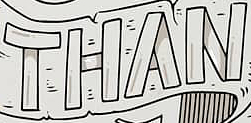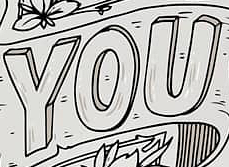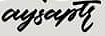Read the text from these images in sequence, separated by a semicolon. THAN; YOU; aysaptr 